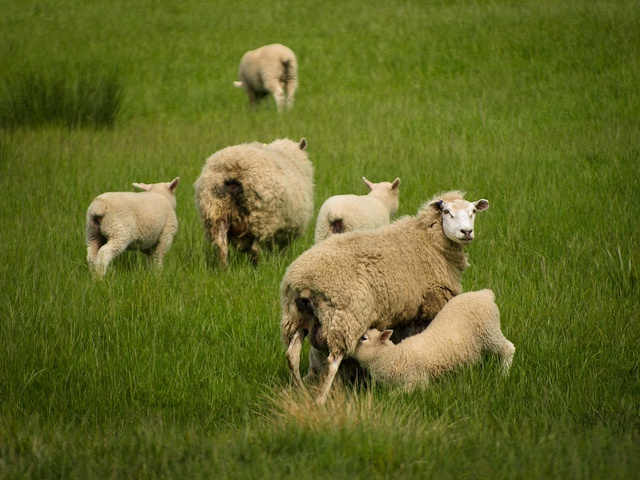Describe the objects in this image and their specific colors. I can see sheep in darkgreen, tan, and olive tones, sheep in darkgreen, tan, olive, and black tones, sheep in darkgreen, tan, and olive tones, sheep in darkgreen, tan, and olive tones, and sheep in darkgreen, tan, and olive tones in this image. 